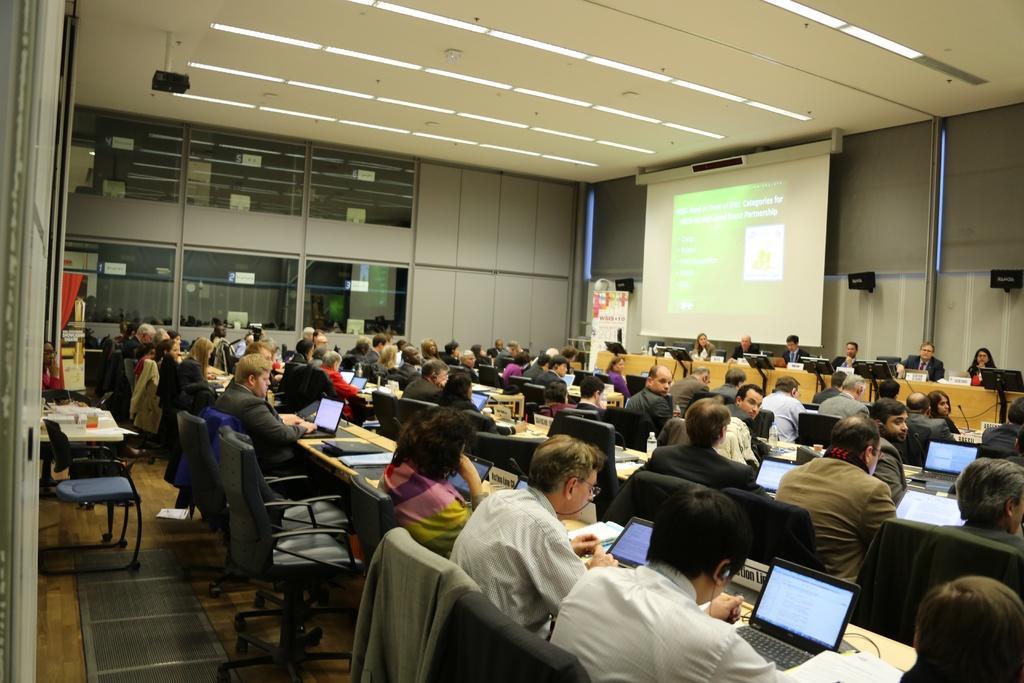How would you summarize this image in a sentence or two? in this image there are more persons sitting at middle of this image as we can see in this image there is a projector wall at right side of this image which is in white color , there is a projector at top left side of this image, and there is a wall in the background. There are some chairs at left side of this image, and there are some laptops as we can see in middle of this image. 